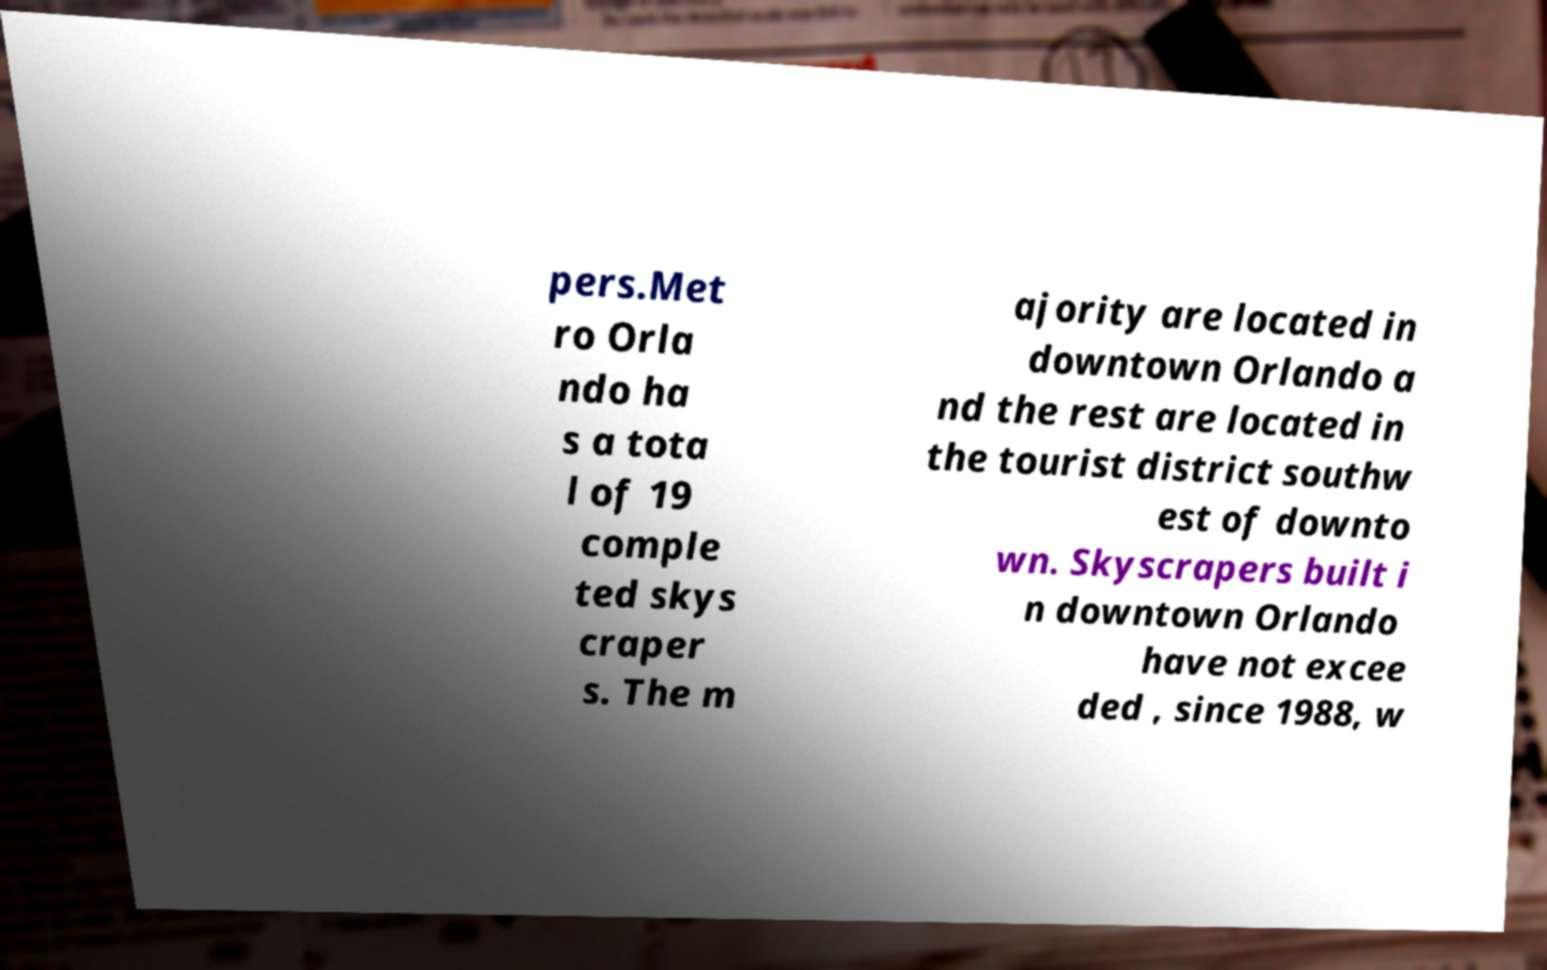Can you read and provide the text displayed in the image?This photo seems to have some interesting text. Can you extract and type it out for me? pers.Met ro Orla ndo ha s a tota l of 19 comple ted skys craper s. The m ajority are located in downtown Orlando a nd the rest are located in the tourist district southw est of downto wn. Skyscrapers built i n downtown Orlando have not excee ded , since 1988, w 